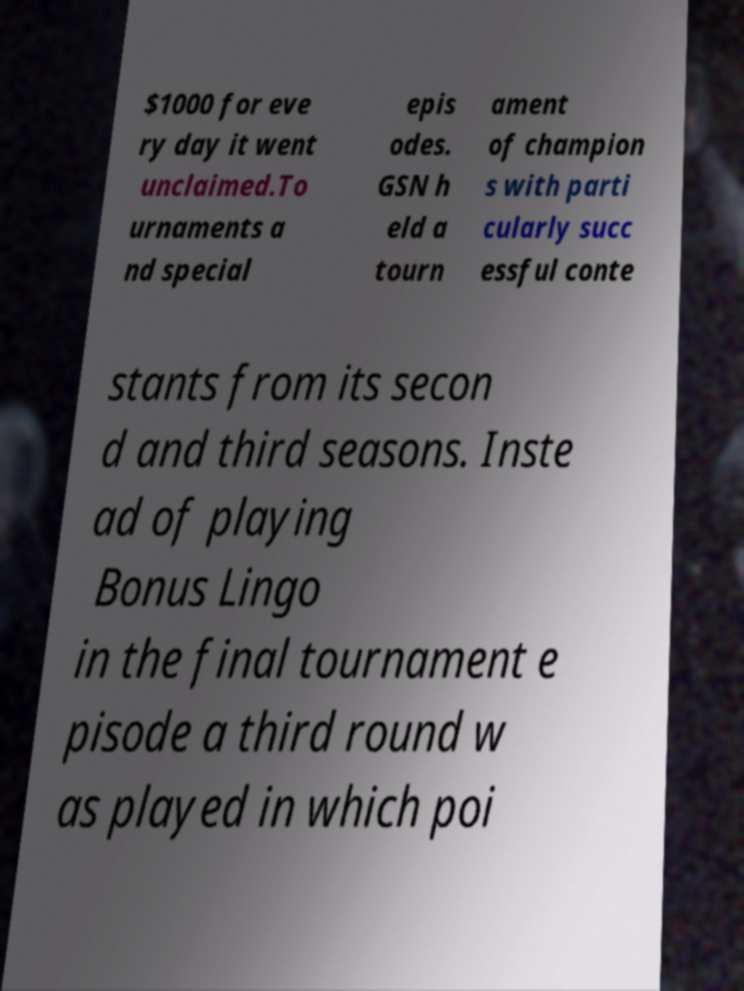There's text embedded in this image that I need extracted. Can you transcribe it verbatim? $1000 for eve ry day it went unclaimed.To urnaments a nd special epis odes. GSN h eld a tourn ament of champion s with parti cularly succ essful conte stants from its secon d and third seasons. Inste ad of playing Bonus Lingo in the final tournament e pisode a third round w as played in which poi 